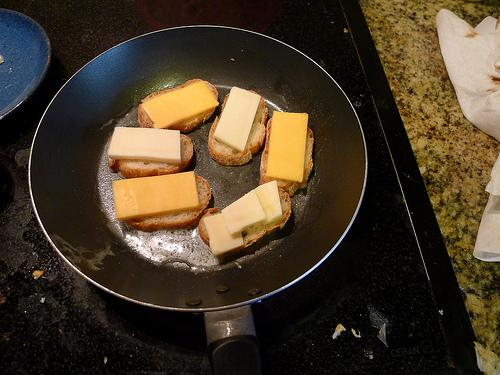Question: how many pieces of bread are there?
Choices:
A. Five.
B. Six.
C. Four.
D. Three.
Answer with the letter. Answer: B Question: why is the cheese on the bread?
Choices:
A. To melt.
B. Flavor.
C. Fat content.
D. Garnish.
Answer with the letter. Answer: A Question: what is in the pan?
Choices:
A. Bread and cheese.
B. Noodles.
C. Sauce.
D. Steak.
Answer with the letter. Answer: A Question: who put the cheese and bread in the pan?
Choices:
A. Mom.
B. Keith Moon.
C. A chef.
D. Roger Waters.
Answer with the letter. Answer: C Question: what is the pan on?
Choices:
A. Counter.
B. A stove.
C. Floor.
D. The table.
Answer with the letter. Answer: B Question: what color is the stove?
Choices:
A. Black.
B. Red.
C. Yellow.
D. White.
Answer with the letter. Answer: A 